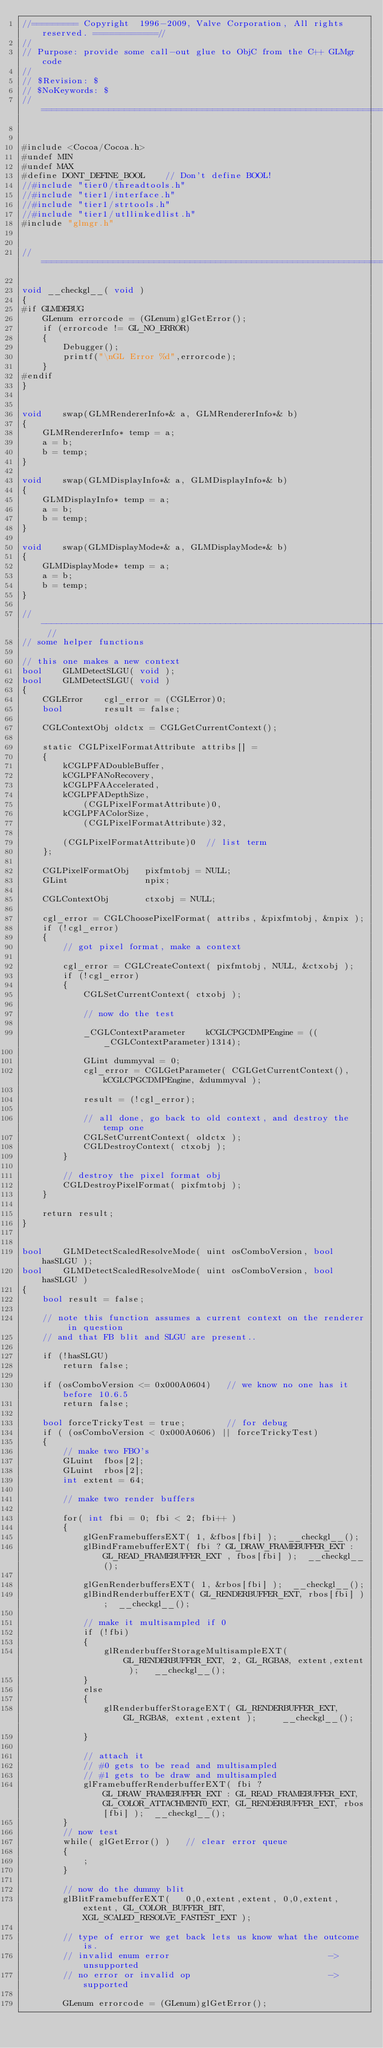Convert code to text. <code><loc_0><loc_0><loc_500><loc_500><_ObjectiveC_>//========= Copyright  1996-2009, Valve Corporation, All rights reserved. ============//
//
// Purpose: provide some call-out glue to ObjC from the C++ GLMgr code
//
// $Revision: $
// $NoKeywords: $
//=============================================================================//


#include <Cocoa/Cocoa.h>
#undef MIN
#undef MAX
#define DONT_DEFINE_BOOL	// Don't define BOOL!
//#include "tier0/threadtools.h"
//#include "tier1/interface.h"
//#include "tier1/strtools.h"
//#include "tier1/utllinkedlist.h"
#include "glmgr.h"


//===============================================================================

void __checkgl__( void )
{
#if GLMDEBUG
	GLenum errorcode = (GLenum)glGetError();
	if (errorcode != GL_NO_ERROR)
	{
		Debugger();
		printf("\nGL Error %d",errorcode);
	}
#endif
}


void	swap(GLMRendererInfo*& a, GLMRendererInfo*& b)
{
	GLMRendererInfo* temp = a;
	a = b;
	b = temp;
}

void	swap(GLMDisplayInfo*& a, GLMDisplayInfo*& b)
{
	GLMDisplayInfo* temp = a;
	a = b;
	b = temp;
}

void	swap(GLMDisplayMode*& a, GLMDisplayMode*& b)
{
	GLMDisplayMode* temp = a;
	a = b;
	b = temp;
}

// ------------------------------------------------------------------------------------ //
// some helper functions

// this one makes a new context
bool	GLMDetectSLGU( void );
bool	GLMDetectSLGU( void )
{
	CGLError	cgl_error = (CGLError)0;
	bool		result = false;
	
	CGLContextObj oldctx = CGLGetCurrentContext();

	static CGLPixelFormatAttribute attribs[] = 
	{
		kCGLPFADoubleBuffer,
		kCGLPFANoRecovery,
		kCGLPFAAccelerated,
		kCGLPFADepthSize,
			(CGLPixelFormatAttribute)0,
		kCGLPFAColorSize,
			(CGLPixelFormatAttribute)32,

		(CGLPixelFormatAttribute)0	// list term
	};

	CGLPixelFormatObj	pixfmtobj = NULL;
	GLint				npix;
	
	CGLContextObj		ctxobj = NULL;
	
	cgl_error = CGLChoosePixelFormat( attribs, &pixfmtobj, &npix );
	if (!cgl_error)
	{
		// got pixel format, make a context
		
		cgl_error = CGLCreateContext( pixfmtobj, NULL, &ctxobj );
		if (!cgl_error)
		{
			CGLSetCurrentContext( ctxobj );

			// now do the test

			_CGLContextParameter	kCGLCPGCDMPEngine = ((_CGLContextParameter)1314);

			GLint dummyval = 0;
			cgl_error = CGLGetParameter( CGLGetCurrentContext(), kCGLCPGCDMPEngine, &dummyval );

			result = (!cgl_error);
			
			// all done, go back to old context, and destroy the temp one
			CGLSetCurrentContext( oldctx );
			CGLDestroyContext( ctxobj );
		}
		
		// destroy the pixel format obj
		CGLDestroyPixelFormat( pixfmtobj );
	}

	return result;
}


bool	GLMDetectScaledResolveMode( uint osComboVersion, bool hasSLGU );
bool	GLMDetectScaledResolveMode( uint osComboVersion, bool hasSLGU )
{
	bool result = false;
	
	// note this function assumes a current context on the renderer in question
	// and that FB blit and SLGU are present..
	
	if (!hasSLGU)
		return false;
		
	if (osComboVersion <= 0x000A0604)	// we know no one has it before 10.6.5
		return false;

	bool forceTrickyTest = true;		// for debug
	if ( (osComboVersion < 0x000A0606) || forceTrickyTest)
	{
		// make two FBO's
		GLuint	fbos[2];
		GLuint	rbos[2];
		int extent = 64;
		
		// make two render buffers

		for( int fbi = 0; fbi < 2; fbi++ )
		{
			glGenFramebuffersEXT( 1, &fbos[fbi] );  __checkgl__();
			glBindFramebufferEXT( fbi ? GL_DRAW_FRAMEBUFFER_EXT : GL_READ_FRAMEBUFFER_EXT , fbos[fbi] );  __checkgl__();

			glGenRenderbuffersEXT( 1, &rbos[fbi] );  __checkgl__();
			glBindRenderbufferEXT( GL_RENDERBUFFER_EXT, rbos[fbi] );  __checkgl__();

			// make it multisampled if 0
			if (!fbi)
			{
				glRenderbufferStorageMultisampleEXT( GL_RENDERBUFFER_EXT, 2, GL_RGBA8, extent,extent );	  __checkgl__();
			}
			else
			{
				glRenderbufferStorageEXT( GL_RENDERBUFFER_EXT, GL_RGBA8, extent,extent );	  __checkgl__();			
			}

			// attach it 
			// #0 gets to be read and multisampled
			// #1 gets to be draw and multisampled
			glFramebufferRenderbufferEXT( fbi ? GL_DRAW_FRAMEBUFFER_EXT : GL_READ_FRAMEBUFFER_EXT, GL_COLOR_ATTACHMENT0_EXT, GL_RENDERBUFFER_EXT, rbos[fbi] );  __checkgl__();			
		}
		// now test
		while( glGetError() )	// clear error queue
		{
			;
		}

		// now do the dummy blit
		glBlitFramebufferEXT(	0,0,extent,extent, 0,0,extent,extent, GL_COLOR_BUFFER_BIT, XGL_SCALED_RESOLVE_FASTEST_EXT );

		// type of error we get back lets us know what the outcome is.
		// invalid enum error								-> unsupported
		// no error or invalid op							-> supported

		GLenum errorcode = (GLenum)glGetError();</code> 